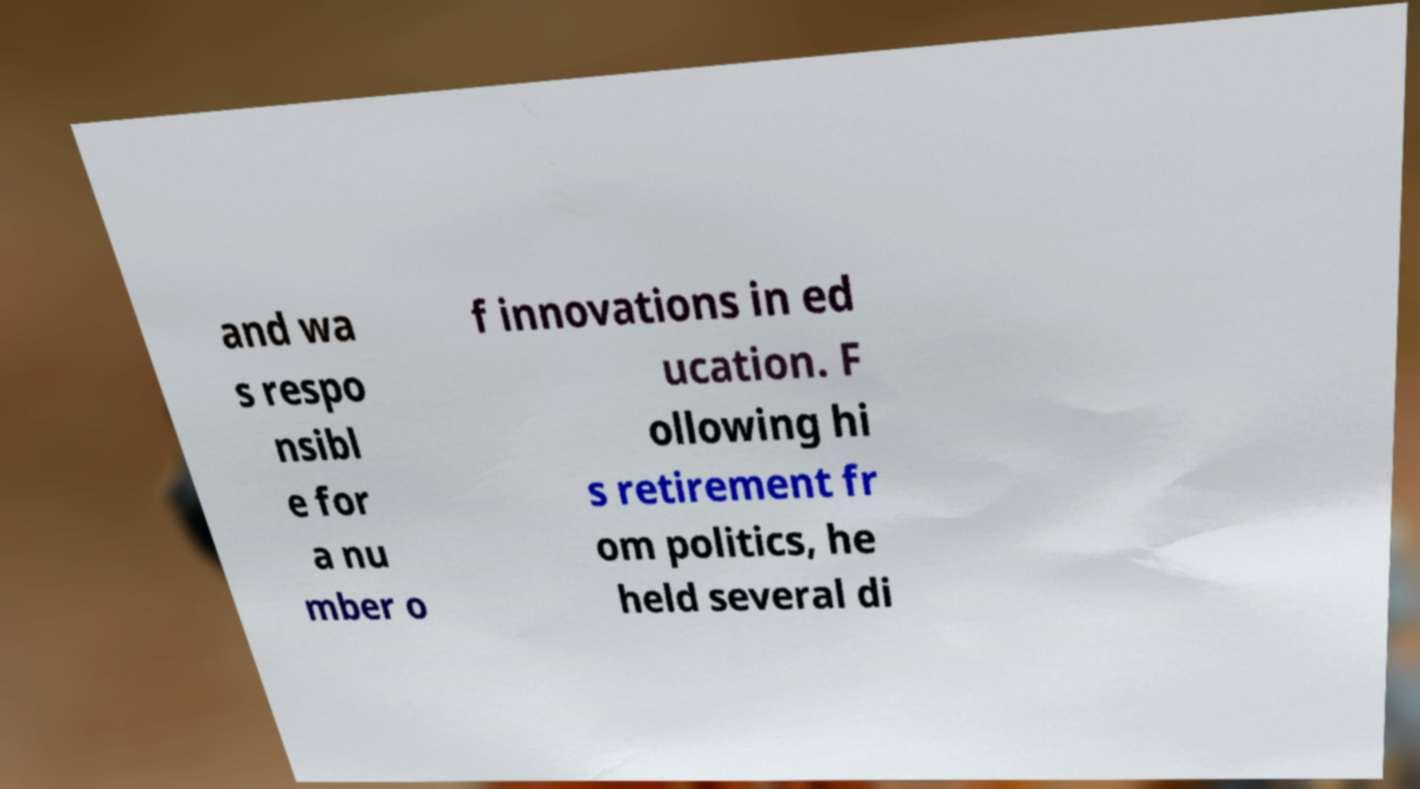Can you read and provide the text displayed in the image?This photo seems to have some interesting text. Can you extract and type it out for me? and wa s respo nsibl e for a nu mber o f innovations in ed ucation. F ollowing hi s retirement fr om politics, he held several di 